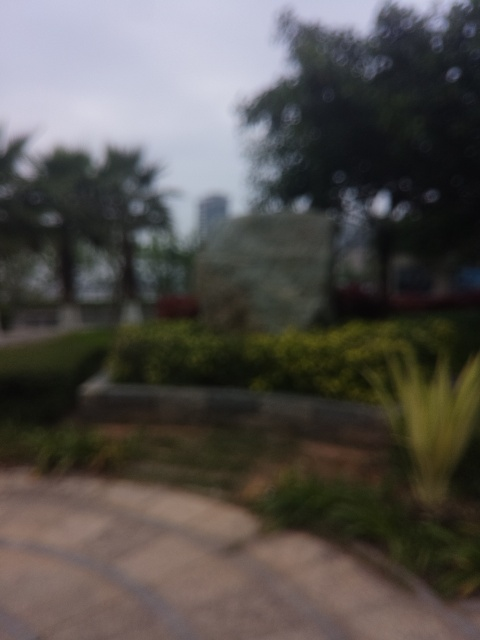Are the details of the stone carving clear? No, the details of the stone carving are not clear in the image provided. The photo is blurry, which obscures the intricate details that might be present on the stone's surface. 